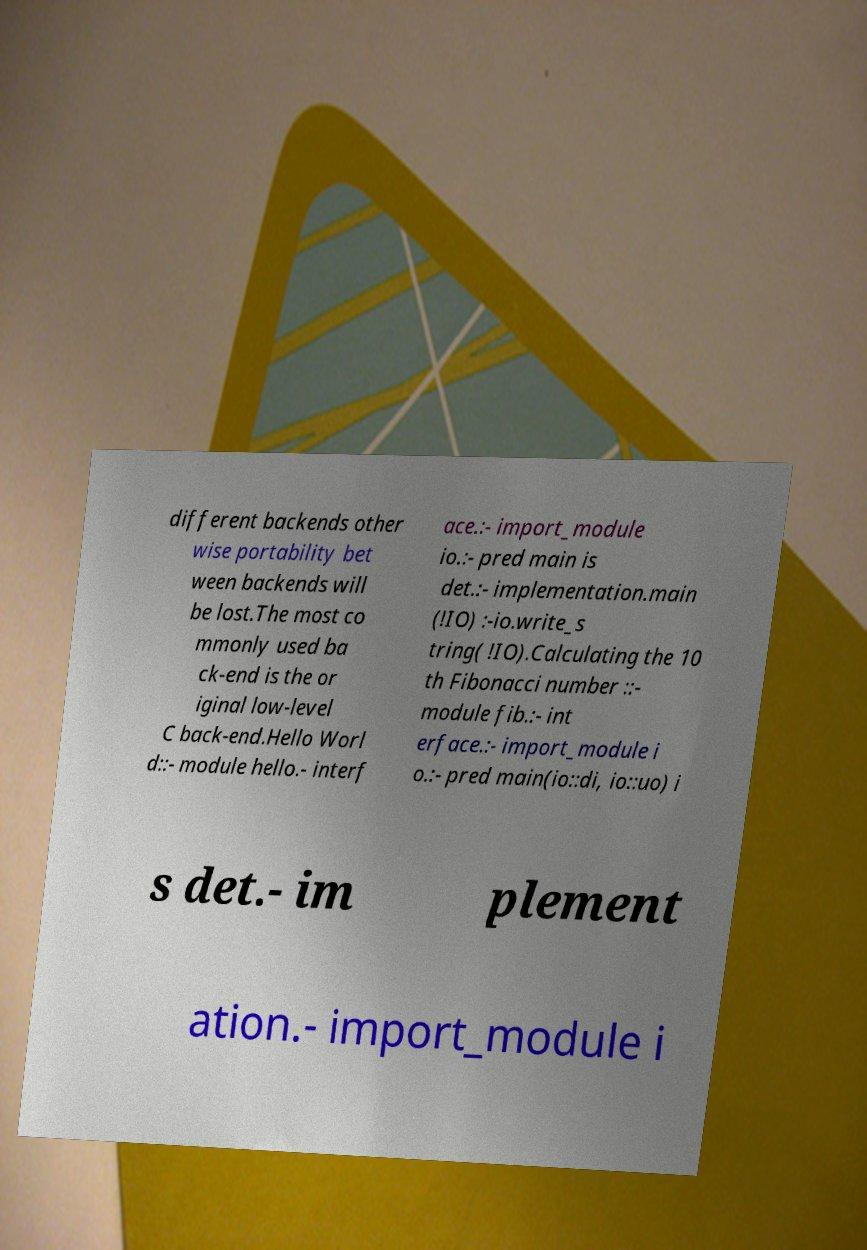There's text embedded in this image that I need extracted. Can you transcribe it verbatim? different backends other wise portability bet ween backends will be lost.The most co mmonly used ba ck-end is the or iginal low-level C back-end.Hello Worl d::- module hello.- interf ace.:- import_module io.:- pred main is det.:- implementation.main (!IO) :-io.write_s tring( !IO).Calculating the 10 th Fibonacci number ::- module fib.:- int erface.:- import_module i o.:- pred main(io::di, io::uo) i s det.- im plement ation.- import_module i 